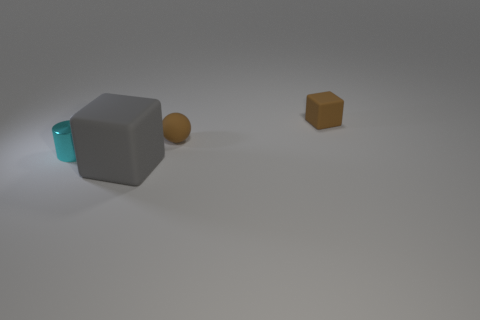Are there fewer big green rubber objects than objects?
Make the answer very short. Yes. How many other things are the same color as the matte ball?
Offer a very short reply. 1. How many tiny cyan objects are there?
Your answer should be very brief. 1. Are there fewer brown rubber blocks that are left of the brown sphere than big yellow balls?
Your answer should be compact. No. Is the material of the cube that is in front of the small brown block the same as the cyan cylinder?
Make the answer very short. No. There is a metallic thing that is behind the thing that is in front of the thing left of the gray cube; what shape is it?
Make the answer very short. Cylinder. Is there a purple shiny cube of the same size as the brown sphere?
Make the answer very short. No. How big is the ball?
Keep it short and to the point. Small. What number of cyan shiny cylinders have the same size as the brown rubber sphere?
Offer a terse response. 1. Are there fewer brown blocks in front of the small cylinder than small things on the right side of the gray thing?
Keep it short and to the point. Yes. 